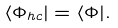Convert formula to latex. <formula><loc_0><loc_0><loc_500><loc_500>\langle \Phi _ { h c } | = \langle \Phi | .</formula> 